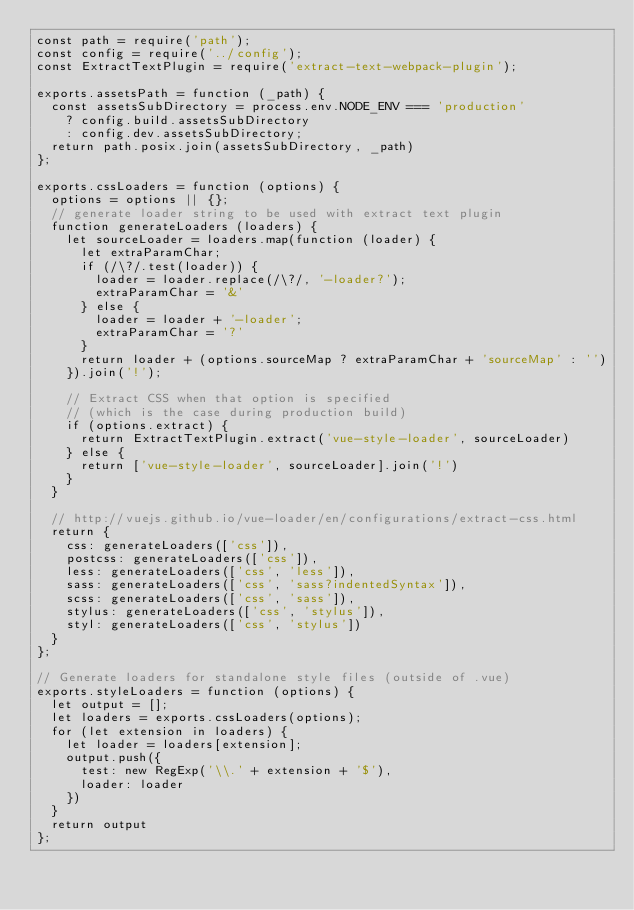<code> <loc_0><loc_0><loc_500><loc_500><_JavaScript_>const path = require('path');
const config = require('../config');
const ExtractTextPlugin = require('extract-text-webpack-plugin');

exports.assetsPath = function (_path) {
  const assetsSubDirectory = process.env.NODE_ENV === 'production'
    ? config.build.assetsSubDirectory
    : config.dev.assetsSubDirectory;
  return path.posix.join(assetsSubDirectory, _path)
};

exports.cssLoaders = function (options) {
  options = options || {};
  // generate loader string to be used with extract text plugin
  function generateLoaders (loaders) {
    let sourceLoader = loaders.map(function (loader) {
      let extraParamChar;
      if (/\?/.test(loader)) {
        loader = loader.replace(/\?/, '-loader?');
        extraParamChar = '&'
      } else {
        loader = loader + '-loader';
        extraParamChar = '?'
      }
      return loader + (options.sourceMap ? extraParamChar + 'sourceMap' : '')
    }).join('!');

    // Extract CSS when that option is specified
    // (which is the case during production build)
    if (options.extract) {
      return ExtractTextPlugin.extract('vue-style-loader', sourceLoader)
    } else {
      return ['vue-style-loader', sourceLoader].join('!')
    }
  }

  // http://vuejs.github.io/vue-loader/en/configurations/extract-css.html
  return {
    css: generateLoaders(['css']),
    postcss: generateLoaders(['css']),
    less: generateLoaders(['css', 'less']),
    sass: generateLoaders(['css', 'sass?indentedSyntax']),
    scss: generateLoaders(['css', 'sass']),
    stylus: generateLoaders(['css', 'stylus']),
    styl: generateLoaders(['css', 'stylus'])
  }
};

// Generate loaders for standalone style files (outside of .vue)
exports.styleLoaders = function (options) {
  let output = [];
  let loaders = exports.cssLoaders(options);
  for (let extension in loaders) {
    let loader = loaders[extension];
    output.push({
      test: new RegExp('\\.' + extension + '$'),
      loader: loader
    })
  }
  return output
};
</code> 